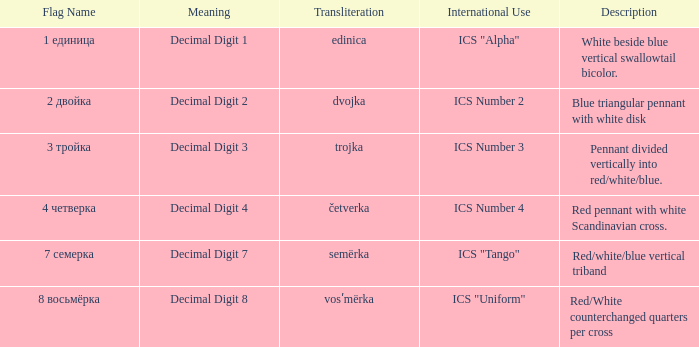What is the international use of the 1 единица flag? ICS "Alpha". 